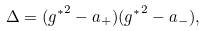<formula> <loc_0><loc_0><loc_500><loc_500>\Delta = ( { g ^ { * } } ^ { 2 } - a _ { + } ) ( { g ^ { * } } ^ { 2 } - a _ { - } ) ,</formula> 